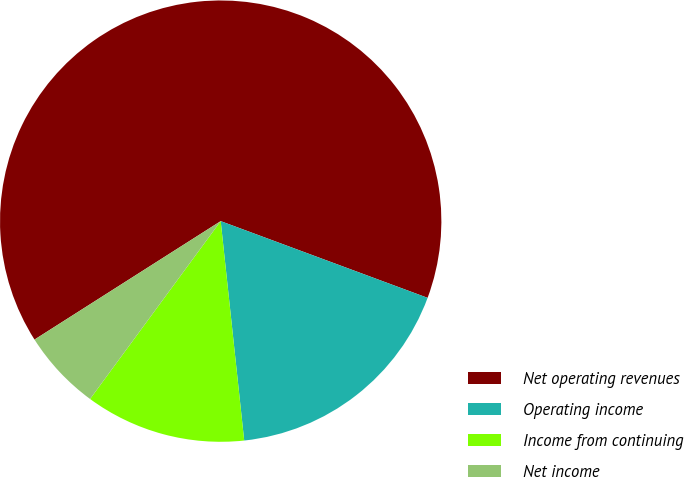Convert chart to OTSL. <chart><loc_0><loc_0><loc_500><loc_500><pie_chart><fcel>Net operating revenues<fcel>Operating income<fcel>Income from continuing<fcel>Net income<nl><fcel>64.67%<fcel>17.65%<fcel>11.78%<fcel>5.9%<nl></chart> 